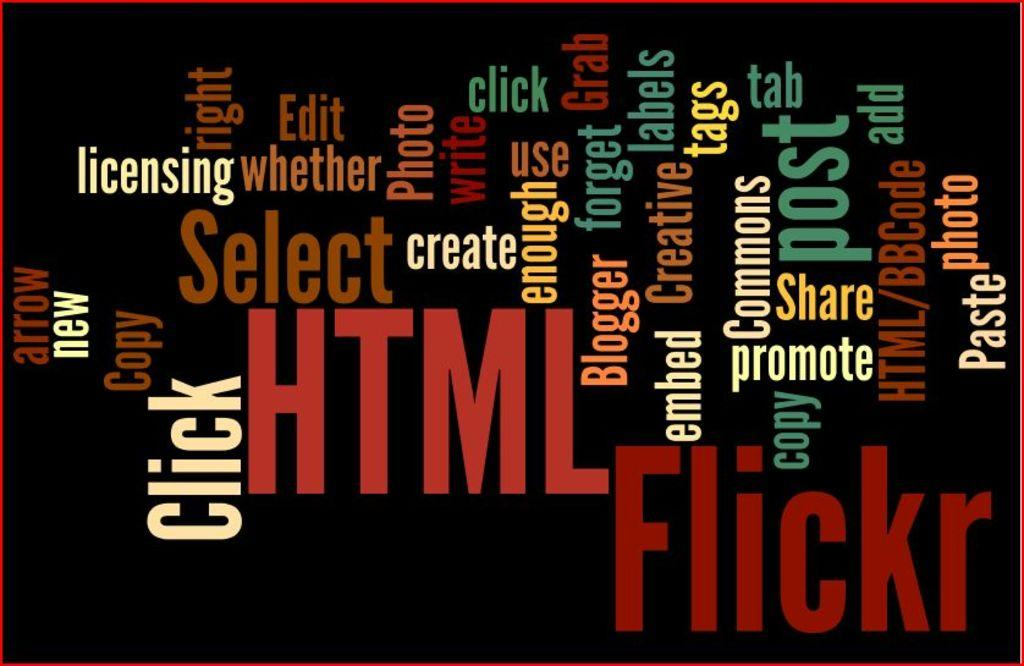<image>
Write a terse but informative summary of the picture. Numerous, various words, which includes "edit", "post", and "share", on a black background. 